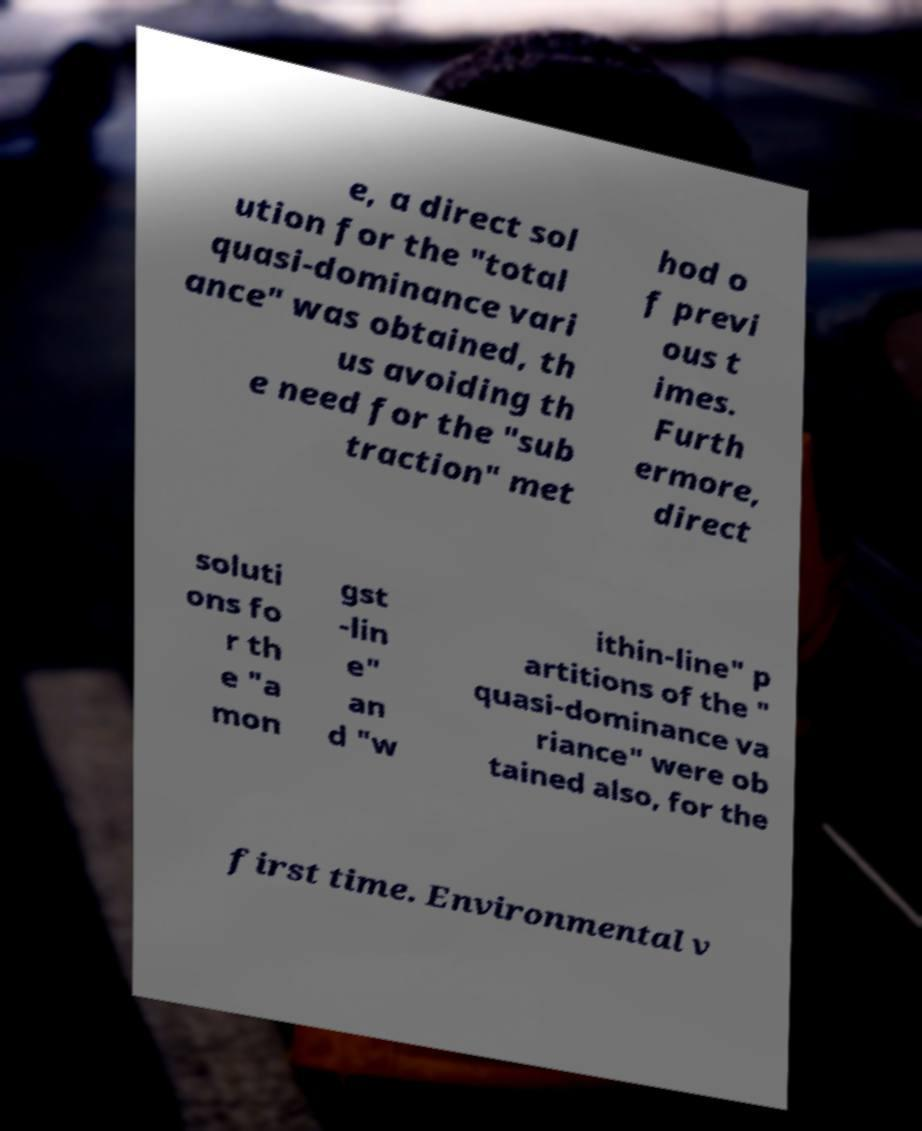Could you assist in decoding the text presented in this image and type it out clearly? e, a direct sol ution for the "total quasi-dominance vari ance" was obtained, th us avoiding th e need for the "sub traction" met hod o f previ ous t imes. Furth ermore, direct soluti ons fo r th e "a mon gst -lin e" an d "w ithin-line" p artitions of the " quasi-dominance va riance" were ob tained also, for the first time. Environmental v 